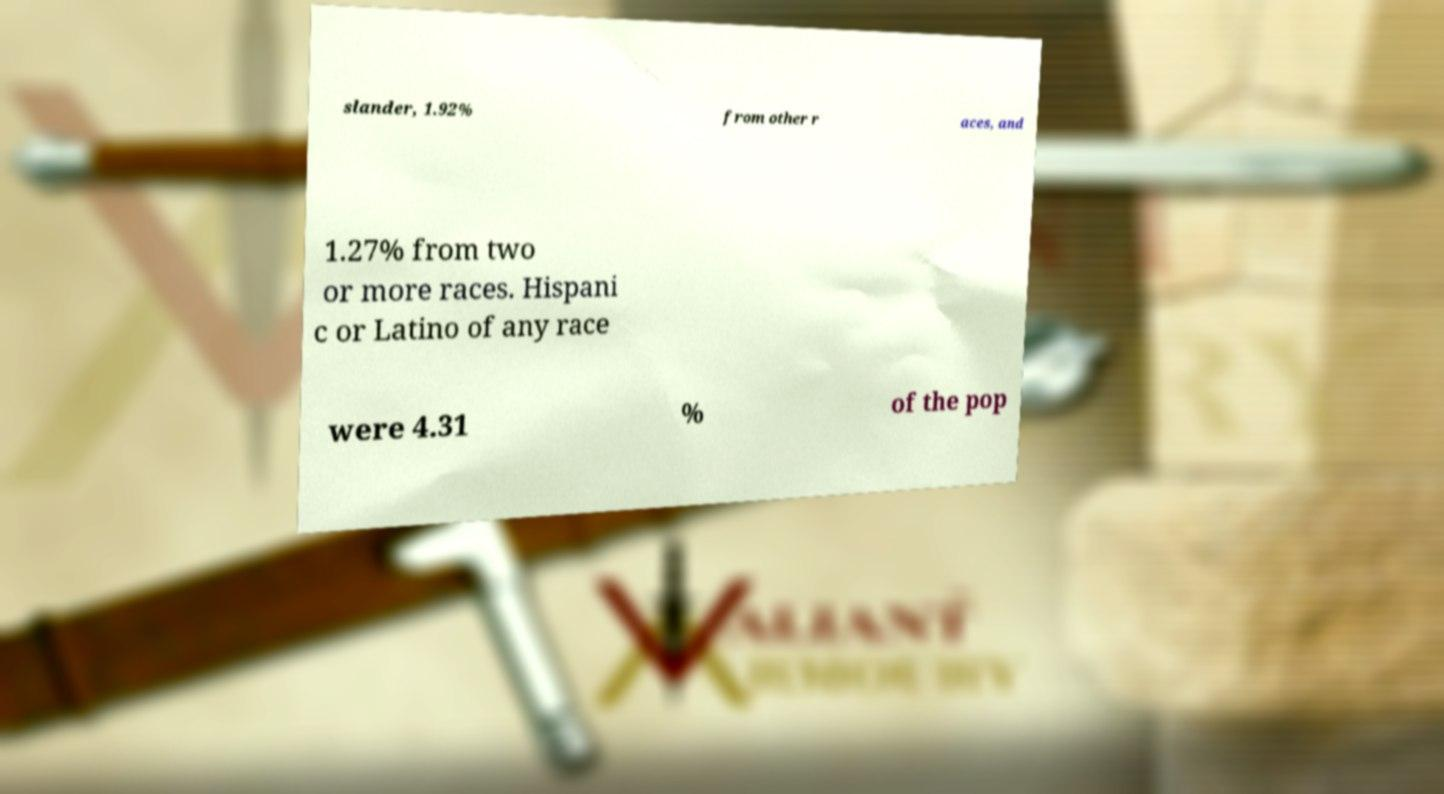What messages or text are displayed in this image? I need them in a readable, typed format. slander, 1.92% from other r aces, and 1.27% from two or more races. Hispani c or Latino of any race were 4.31 % of the pop 